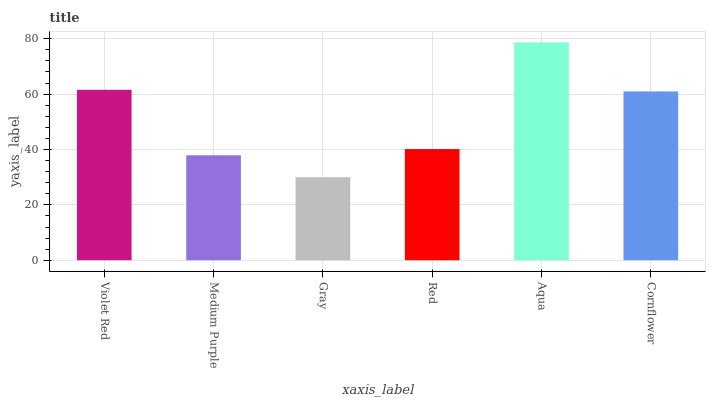Is Medium Purple the minimum?
Answer yes or no. No. Is Medium Purple the maximum?
Answer yes or no. No. Is Violet Red greater than Medium Purple?
Answer yes or no. Yes. Is Medium Purple less than Violet Red?
Answer yes or no. Yes. Is Medium Purple greater than Violet Red?
Answer yes or no. No. Is Violet Red less than Medium Purple?
Answer yes or no. No. Is Cornflower the high median?
Answer yes or no. Yes. Is Red the low median?
Answer yes or no. Yes. Is Violet Red the high median?
Answer yes or no. No. Is Medium Purple the low median?
Answer yes or no. No. 